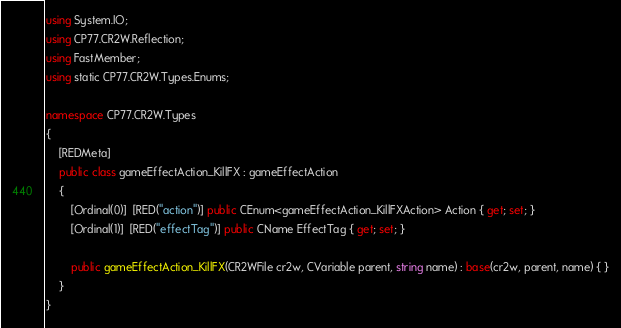Convert code to text. <code><loc_0><loc_0><loc_500><loc_500><_C#_>using System.IO;
using CP77.CR2W.Reflection;
using FastMember;
using static CP77.CR2W.Types.Enums;

namespace CP77.CR2W.Types
{
	[REDMeta]
	public class gameEffectAction_KillFX : gameEffectAction
	{
		[Ordinal(0)]  [RED("action")] public CEnum<gameEffectAction_KillFXAction> Action { get; set; }
		[Ordinal(1)]  [RED("effectTag")] public CName EffectTag { get; set; }

		public gameEffectAction_KillFX(CR2WFile cr2w, CVariable parent, string name) : base(cr2w, parent, name) { }
	}
}
</code> 